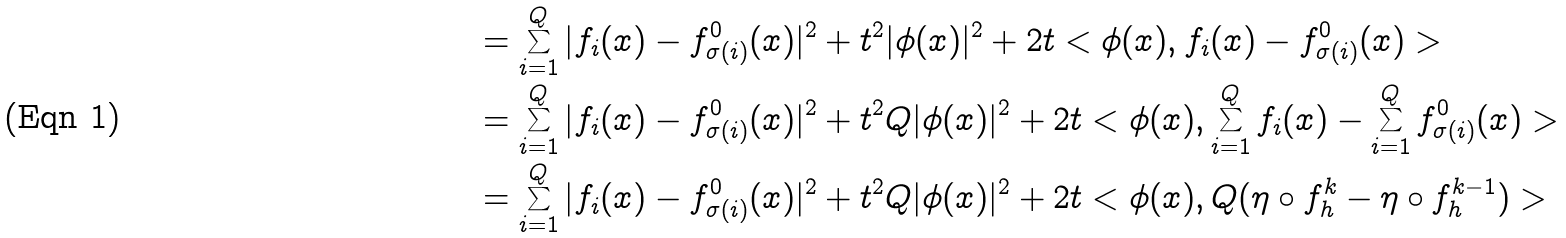<formula> <loc_0><loc_0><loc_500><loc_500>& = \sum _ { i = 1 } ^ { Q } | f _ { i } ( x ) - f _ { \sigma ( i ) } ^ { 0 } ( x ) | ^ { 2 } + t ^ { 2 } | \phi ( x ) | ^ { 2 } + 2 t < \phi ( x ) , f _ { i } ( x ) - f _ { \sigma ( i ) } ^ { 0 } ( x ) > \\ & = \sum _ { i = 1 } ^ { Q } | f _ { i } ( x ) - f _ { \sigma ( i ) } ^ { 0 } ( x ) | ^ { 2 } + t ^ { 2 } Q | \phi ( x ) | ^ { 2 } + 2 t < \phi ( x ) , \sum _ { i = 1 } ^ { Q } f _ { i } ( x ) - \sum _ { i = 1 } ^ { Q } f _ { \sigma ( i ) } ^ { 0 } ( x ) > \\ & = \sum _ { i = 1 } ^ { Q } | f _ { i } ( x ) - f _ { \sigma ( i ) } ^ { 0 } ( x ) | ^ { 2 } + t ^ { 2 } Q | \phi ( x ) | ^ { 2 } + 2 t < \phi ( x ) , Q ( \eta \circ f _ { h } ^ { k } - \eta \circ f _ { h } ^ { k - 1 } ) ></formula> 